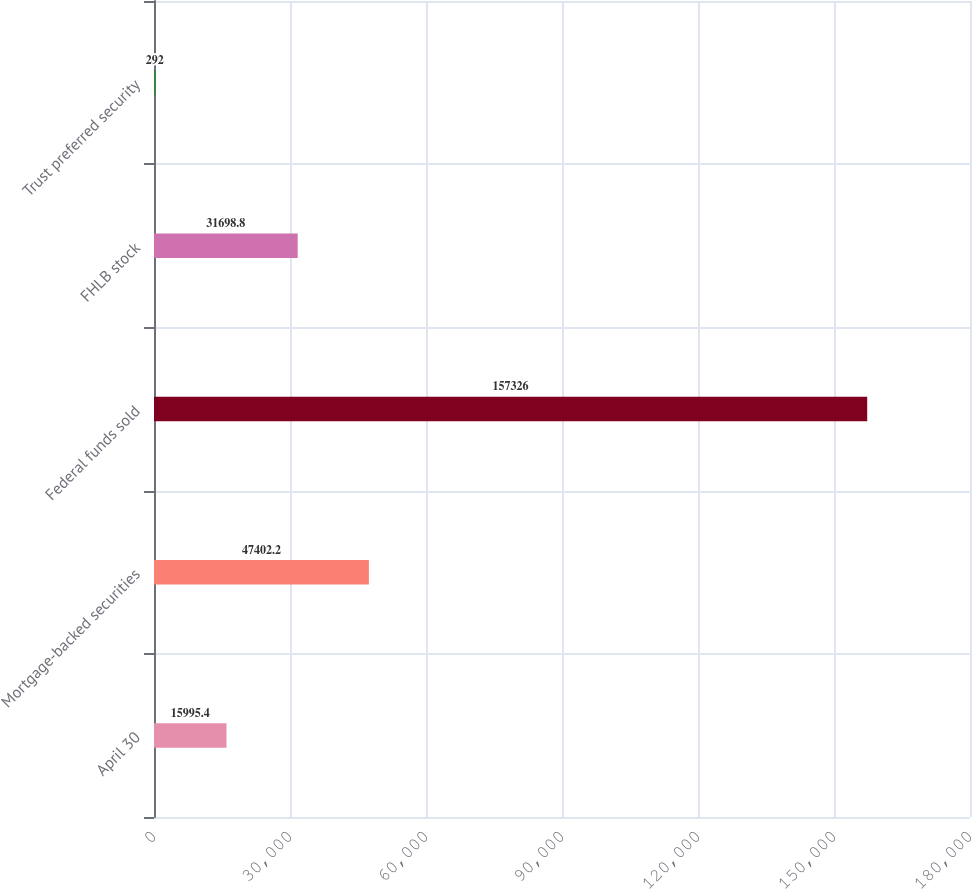Convert chart. <chart><loc_0><loc_0><loc_500><loc_500><bar_chart><fcel>April 30<fcel>Mortgage-backed securities<fcel>Federal funds sold<fcel>FHLB stock<fcel>Trust preferred security<nl><fcel>15995.4<fcel>47402.2<fcel>157326<fcel>31698.8<fcel>292<nl></chart> 